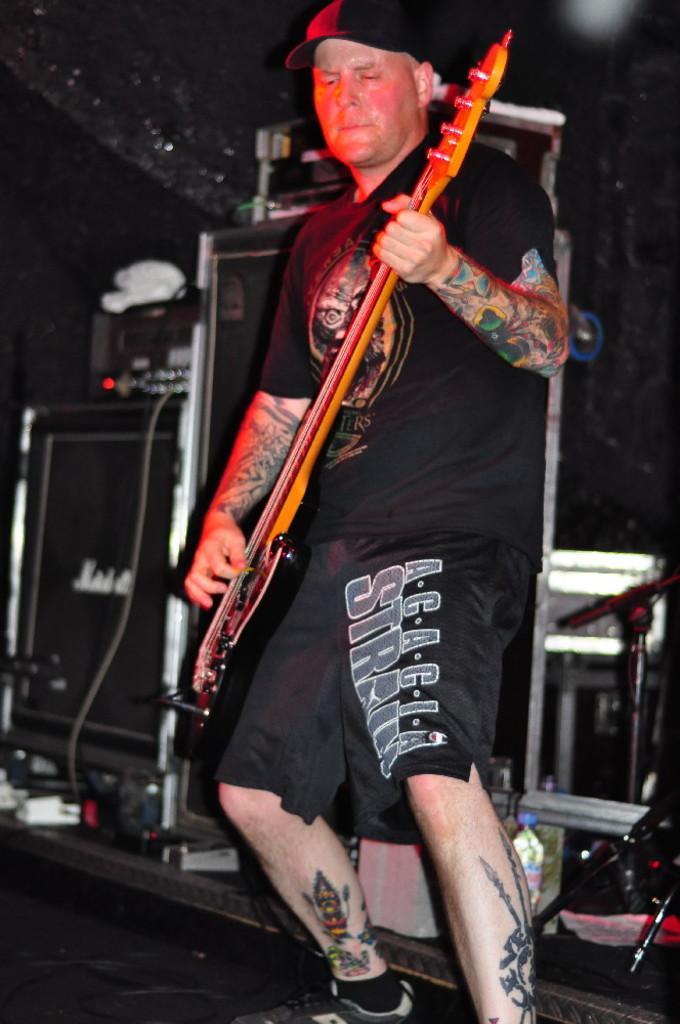Can you describe this image briefly? In this picture I can see a man standing in front and I see that, he is holding a guitar and I can also see tattoos on his legs and hands. In the background I can see few equipment. 